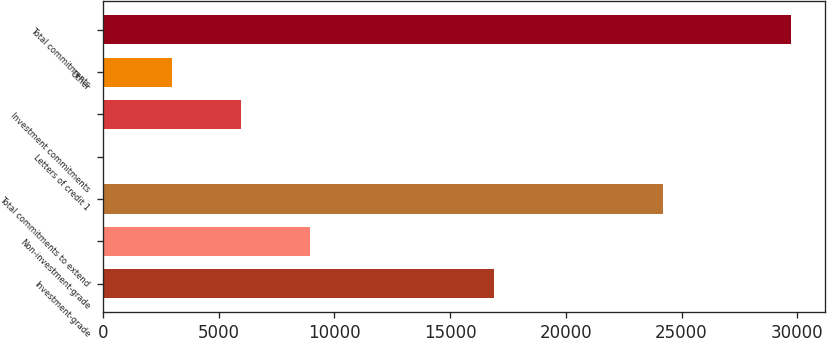Convert chart. <chart><loc_0><loc_0><loc_500><loc_500><bar_chart><fcel>Investment-grade<fcel>Non-investment-grade<fcel>Total commitments to extend<fcel>Letters of credit 1<fcel>Investment commitments<fcel>Other<fcel>Total commitments<nl><fcel>16903<fcel>8931.9<fcel>24214<fcel>21<fcel>5961.6<fcel>2991.3<fcel>29724<nl></chart> 